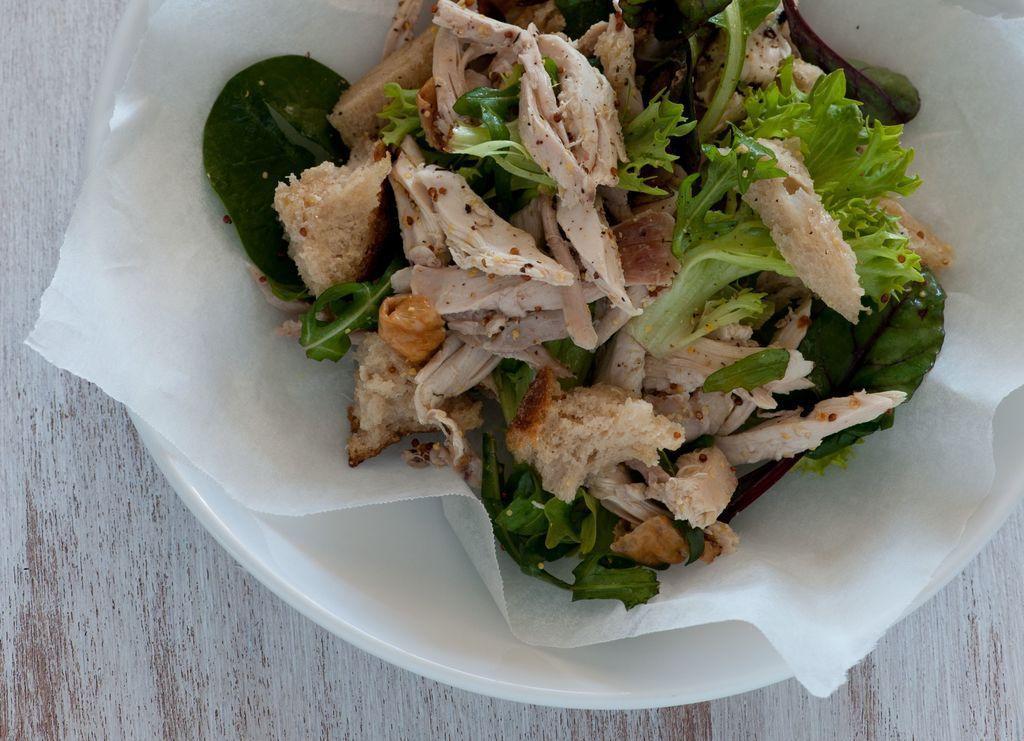What is present in the image? There is food in the image. Where is the food located? The food is placed on a table. What verse is being recited by the food in the image? There is no verse being recited by the food in the image, as food does not have the ability to recite verses. 